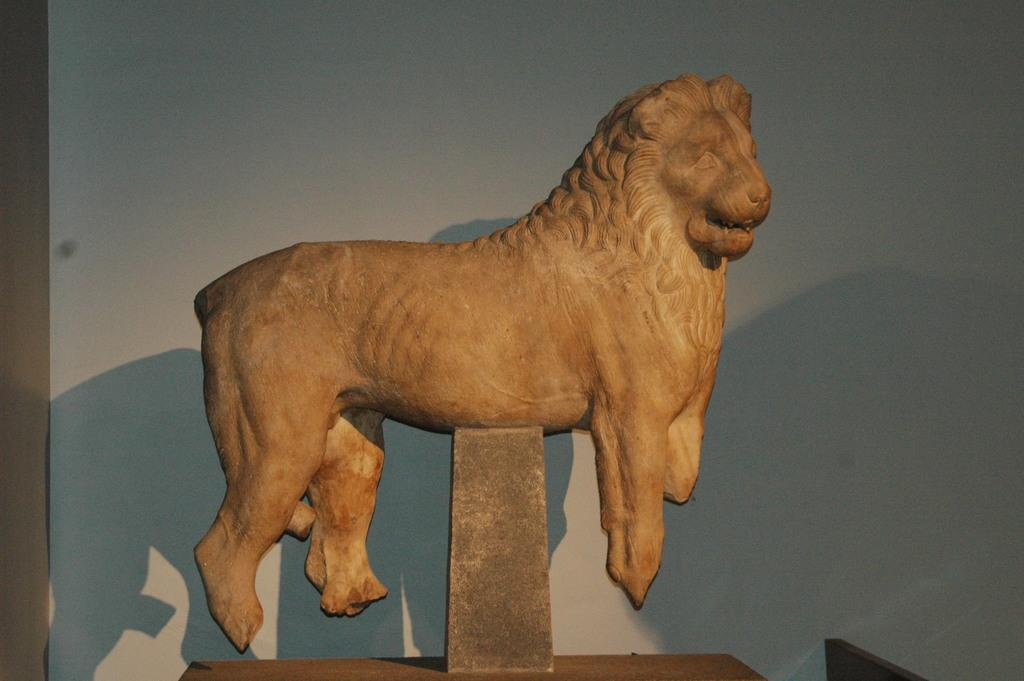What is the main subject of the image? There is a statue of an animal in the image. What color is the statue? The statue is brown in color. What can be seen in the background of the image? There is a white wall in the background of the image. How many drops of water are falling from the statue in the image? There are no drops of water visible in the image; the statue is a stationary object. 